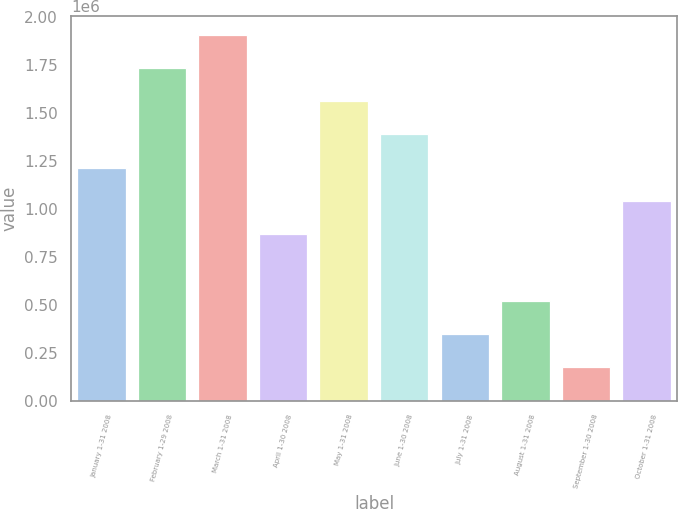<chart> <loc_0><loc_0><loc_500><loc_500><bar_chart><fcel>January 1-31 2008<fcel>February 1-29 2008<fcel>March 1-31 2008<fcel>April 1-30 2008<fcel>May 1-31 2008<fcel>June 1-30 2008<fcel>July 1-31 2008<fcel>August 1-31 2008<fcel>September 1-30 2008<fcel>October 1-31 2008<nl><fcel>1.21576e+06<fcel>1.7368e+06<fcel>1.91048e+06<fcel>868400<fcel>1.56312e+06<fcel>1.38944e+06<fcel>347360<fcel>521040<fcel>173681<fcel>1.04208e+06<nl></chart> 